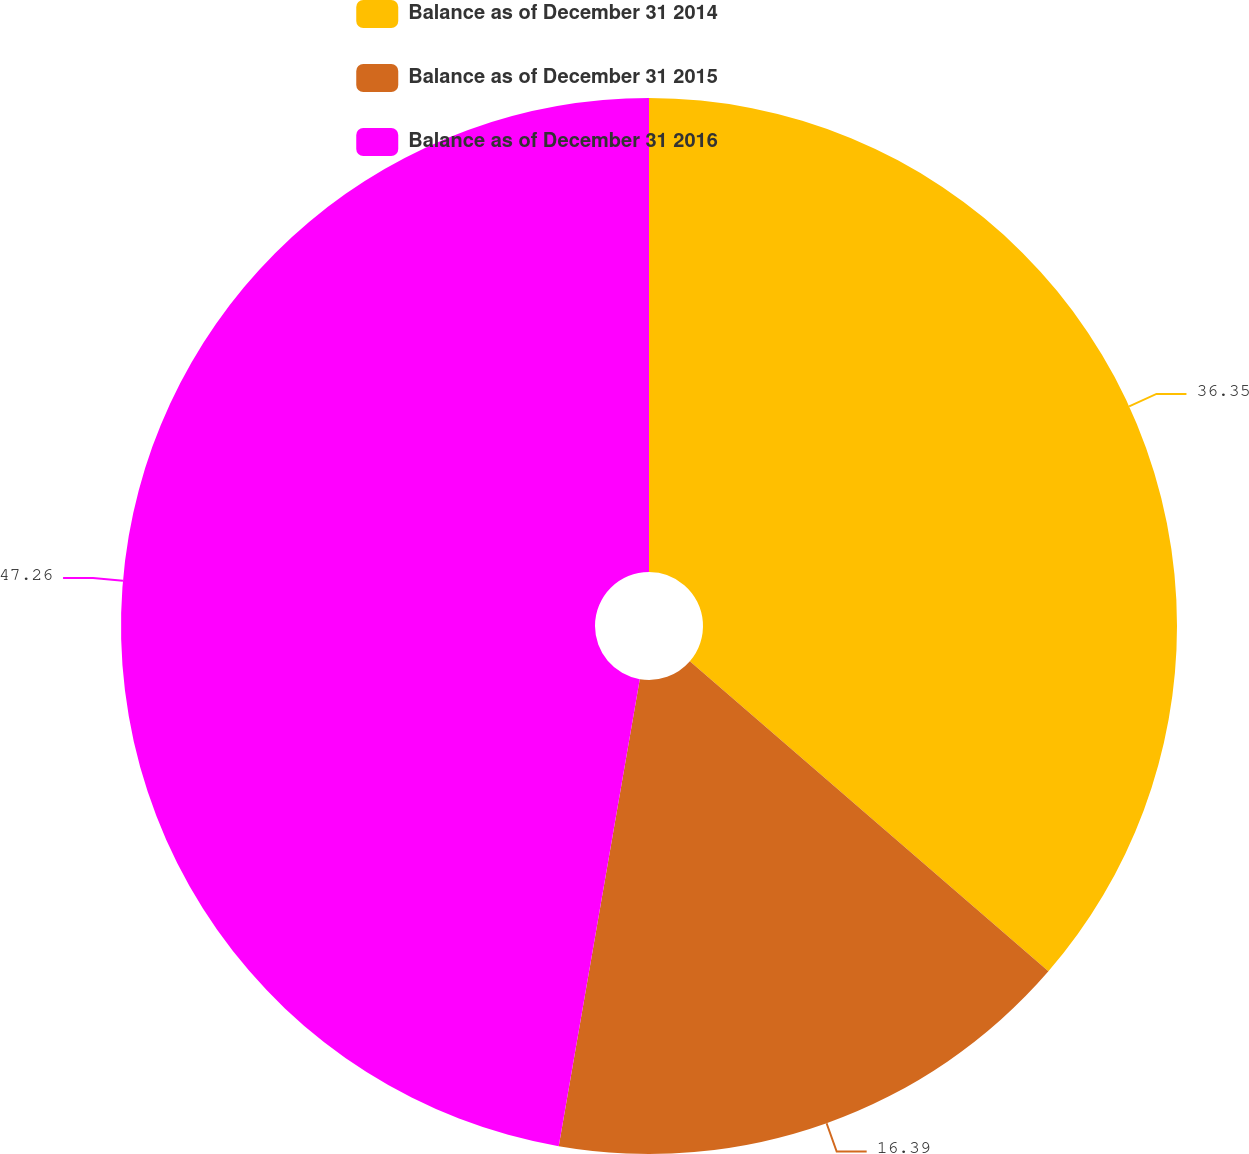<chart> <loc_0><loc_0><loc_500><loc_500><pie_chart><fcel>Balance as of December 31 2014<fcel>Balance as of December 31 2015<fcel>Balance as of December 31 2016<nl><fcel>36.35%<fcel>16.39%<fcel>47.27%<nl></chart> 